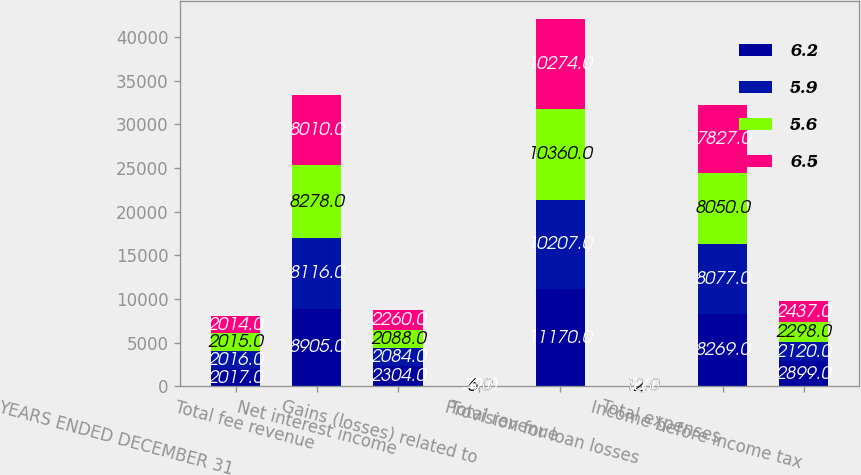<chart> <loc_0><loc_0><loc_500><loc_500><stacked_bar_chart><ecel><fcel>YEARS ENDED DECEMBER 31<fcel>Total fee revenue<fcel>Net interest income<fcel>Gains (losses) related to<fcel>Total revenue<fcel>Provision for loan losses<fcel>Total expenses<fcel>Income before income tax<nl><fcel>6.2<fcel>2017<fcel>8905<fcel>2304<fcel>39<fcel>11170<fcel>2<fcel>8269<fcel>2899<nl><fcel>5.9<fcel>2016<fcel>8116<fcel>2084<fcel>7<fcel>10207<fcel>10<fcel>8077<fcel>2120<nl><fcel>5.6<fcel>2015<fcel>8278<fcel>2088<fcel>6<fcel>10360<fcel>12<fcel>8050<fcel>2298<nl><fcel>6.5<fcel>2014<fcel>8010<fcel>2260<fcel>4<fcel>10274<fcel>10<fcel>7827<fcel>2437<nl></chart> 